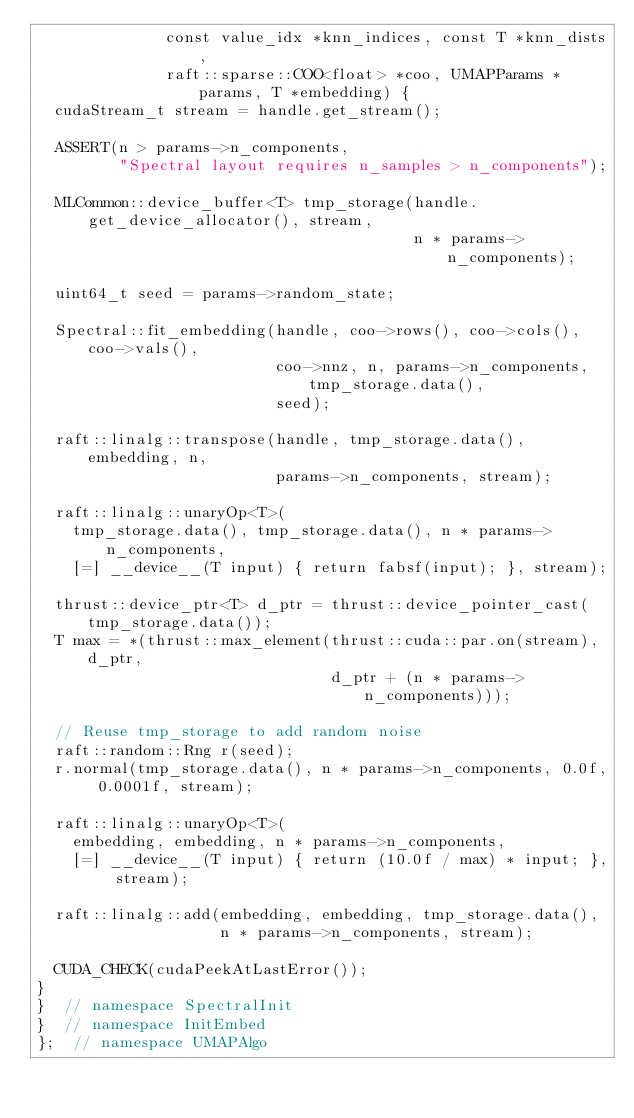<code> <loc_0><loc_0><loc_500><loc_500><_Cuda_>              const value_idx *knn_indices, const T *knn_dists,
              raft::sparse::COO<float> *coo, UMAPParams *params, T *embedding) {
  cudaStream_t stream = handle.get_stream();

  ASSERT(n > params->n_components,
         "Spectral layout requires n_samples > n_components");

  MLCommon::device_buffer<T> tmp_storage(handle.get_device_allocator(), stream,
                                         n * params->n_components);

  uint64_t seed = params->random_state;

  Spectral::fit_embedding(handle, coo->rows(), coo->cols(), coo->vals(),
                          coo->nnz, n, params->n_components, tmp_storage.data(),
                          seed);

  raft::linalg::transpose(handle, tmp_storage.data(), embedding, n,
                          params->n_components, stream);

  raft::linalg::unaryOp<T>(
    tmp_storage.data(), tmp_storage.data(), n * params->n_components,
    [=] __device__(T input) { return fabsf(input); }, stream);

  thrust::device_ptr<T> d_ptr = thrust::device_pointer_cast(tmp_storage.data());
  T max = *(thrust::max_element(thrust::cuda::par.on(stream), d_ptr,
                                d_ptr + (n * params->n_components)));

  // Reuse tmp_storage to add random noise
  raft::random::Rng r(seed);
  r.normal(tmp_storage.data(), n * params->n_components, 0.0f, 0.0001f, stream);

  raft::linalg::unaryOp<T>(
    embedding, embedding, n * params->n_components,
    [=] __device__(T input) { return (10.0f / max) * input; }, stream);

  raft::linalg::add(embedding, embedding, tmp_storage.data(),
                    n * params->n_components, stream);

  CUDA_CHECK(cudaPeekAtLastError());
}
}  // namespace SpectralInit
}  // namespace InitEmbed
};  // namespace UMAPAlgo
</code> 